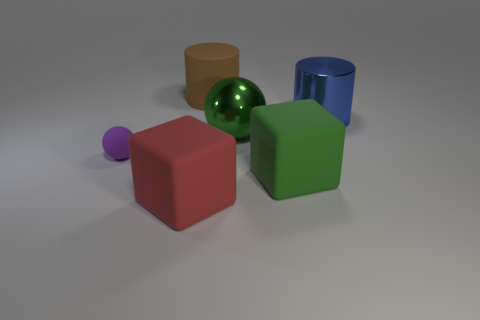Add 3 small cyan rubber spheres. How many objects exist? 9 Subtract all cylinders. How many objects are left? 4 Add 2 large blue metal cylinders. How many large blue metal cylinders exist? 3 Subtract 1 green spheres. How many objects are left? 5 Subtract all large cyan shiny spheres. Subtract all large red matte blocks. How many objects are left? 5 Add 3 rubber objects. How many rubber objects are left? 7 